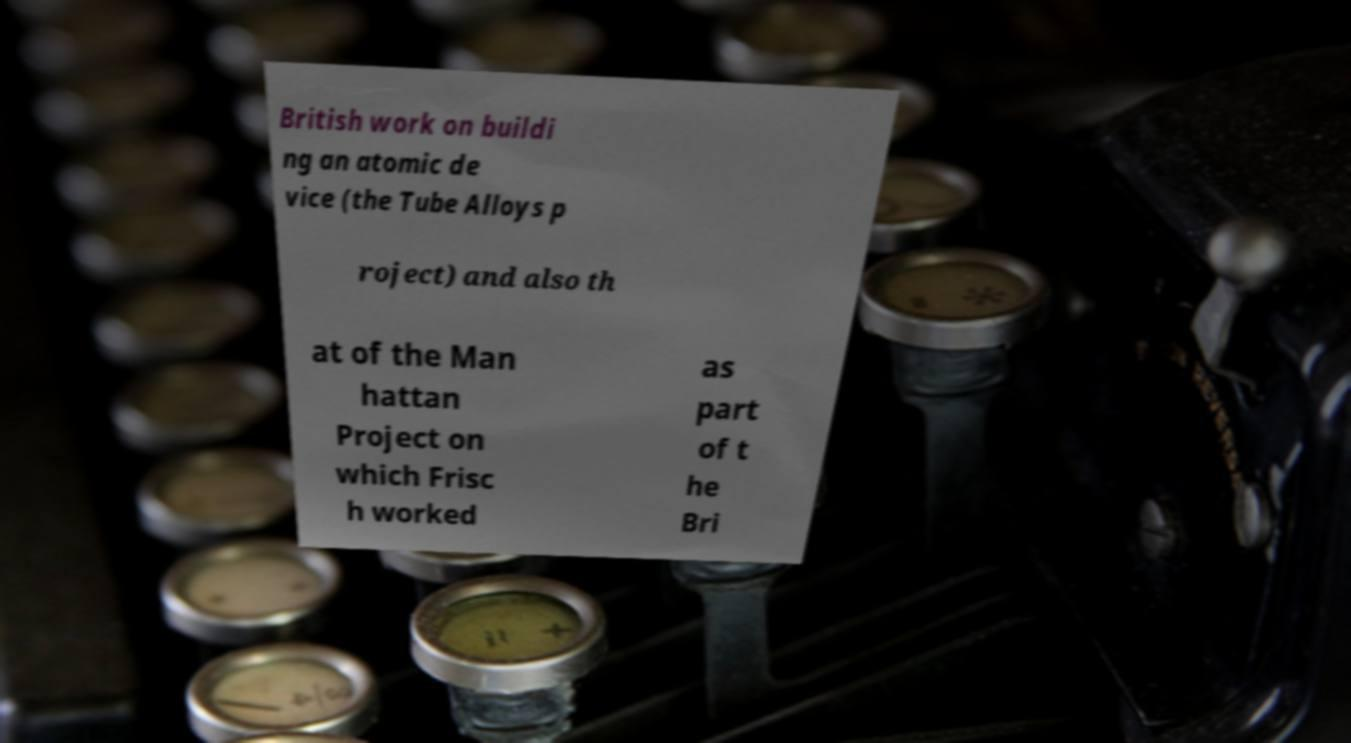Could you extract and type out the text from this image? British work on buildi ng an atomic de vice (the Tube Alloys p roject) and also th at of the Man hattan Project on which Frisc h worked as part of t he Bri 